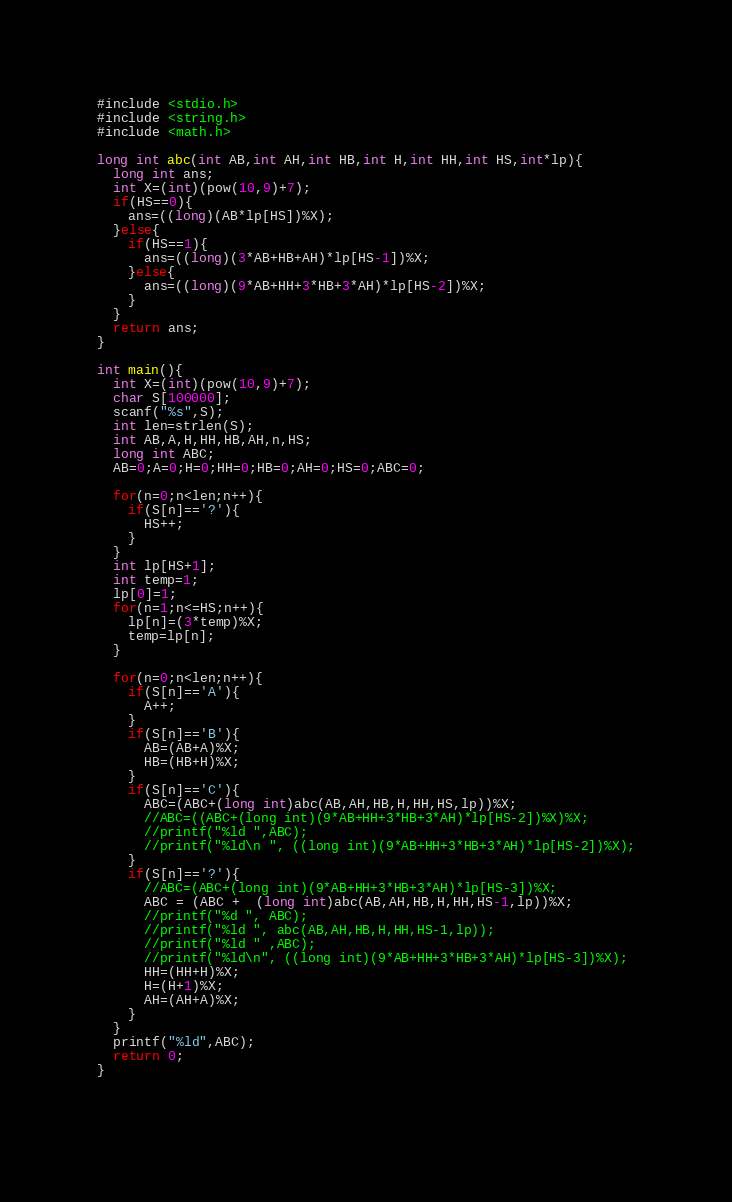<code> <loc_0><loc_0><loc_500><loc_500><_C_>#include <stdio.h>
#include <string.h>
#include <math.h>

long int abc(int AB,int AH,int HB,int H,int HH,int HS,int*lp){
  long int ans;
  int X=(int)(pow(10,9)+7);
  if(HS==0){
    ans=((long)(AB*lp[HS])%X);
  }else{
    if(HS==1){
      ans=((long)(3*AB+HB+AH)*lp[HS-1])%X;
    }else{
      ans=((long)(9*AB+HH+3*HB+3*AH)*lp[HS-2])%X;
    }
  }
  return ans;
}

int main(){
  int X=(int)(pow(10,9)+7);
  char S[100000];
  scanf("%s",S);
  int len=strlen(S);
  int AB,A,H,HH,HB,AH,n,HS;
  long int ABC;
  AB=0;A=0;H=0;HH=0;HB=0;AH=0;HS=0;ABC=0;

  for(n=0;n<len;n++){
    if(S[n]=='?'){
      HS++;
    }
  }
  int lp[HS+1];
  int temp=1;
  lp[0]=1;
  for(n=1;n<=HS;n++){
    lp[n]=(3*temp)%X;
    temp=lp[n];
  }
  
  for(n=0;n<len;n++){
    if(S[n]=='A'){
      A++;
    }
    if(S[n]=='B'){
      AB=(AB+A)%X;
      HB=(HB+H)%X;
    }
    if(S[n]=='C'){
      ABC=(ABC+(long int)abc(AB,AH,HB,H,HH,HS,lp))%X;
      //ABC=((ABC+(long int)(9*AB+HH+3*HB+3*AH)*lp[HS-2])%X)%X;
      //printf("%ld ",ABC);
      //printf("%ld\n ", ((long int)(9*AB+HH+3*HB+3*AH)*lp[HS-2])%X);
    }
    if(S[n]=='?'){
      //ABC=(ABC+(long int)(9*AB+HH+3*HB+3*AH)*lp[HS-3])%X;
      ABC = (ABC +  (long int)abc(AB,AH,HB,H,HH,HS-1,lp))%X;
      //printf("%d ", ABC);
      //printf("%ld ", abc(AB,AH,HB,H,HH,HS-1,lp));
      //printf("%ld " ,ABC);
      //printf("%ld\n", ((long int)(9*AB+HH+3*HB+3*AH)*lp[HS-3])%X);
      HH=(HH+H)%X;
      H=(H+1)%X;
      AH=(AH+A)%X;
    }
  }
  printf("%ld",ABC);
  return 0;
}

  
</code> 